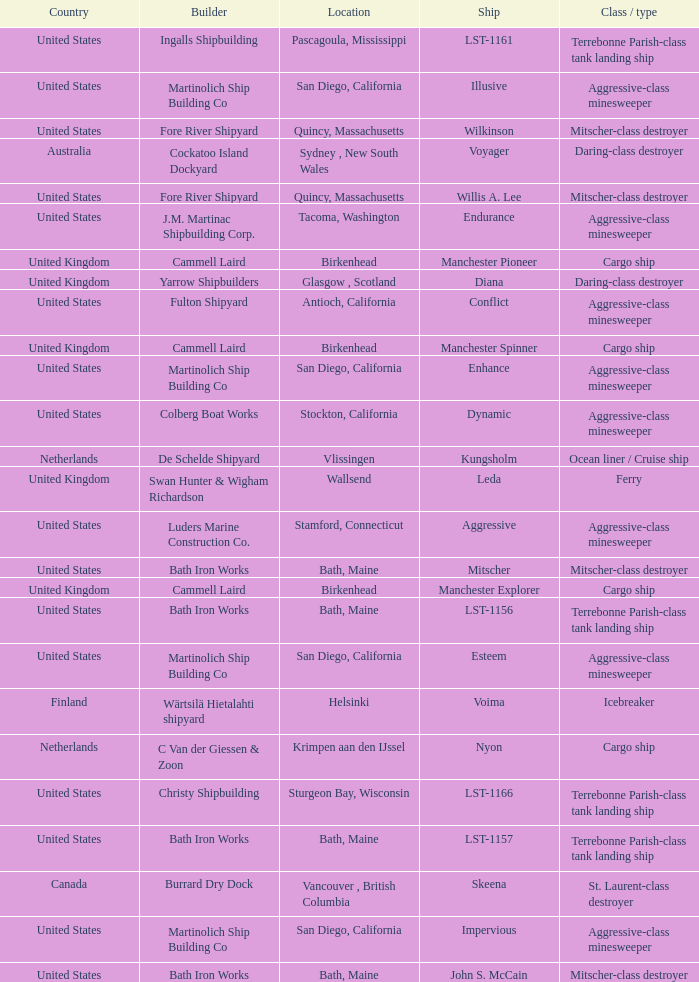What is the Cargo Ship located at Birkenhead? Manchester Pioneer, Manchester Spinner, Manchester Explorer. 